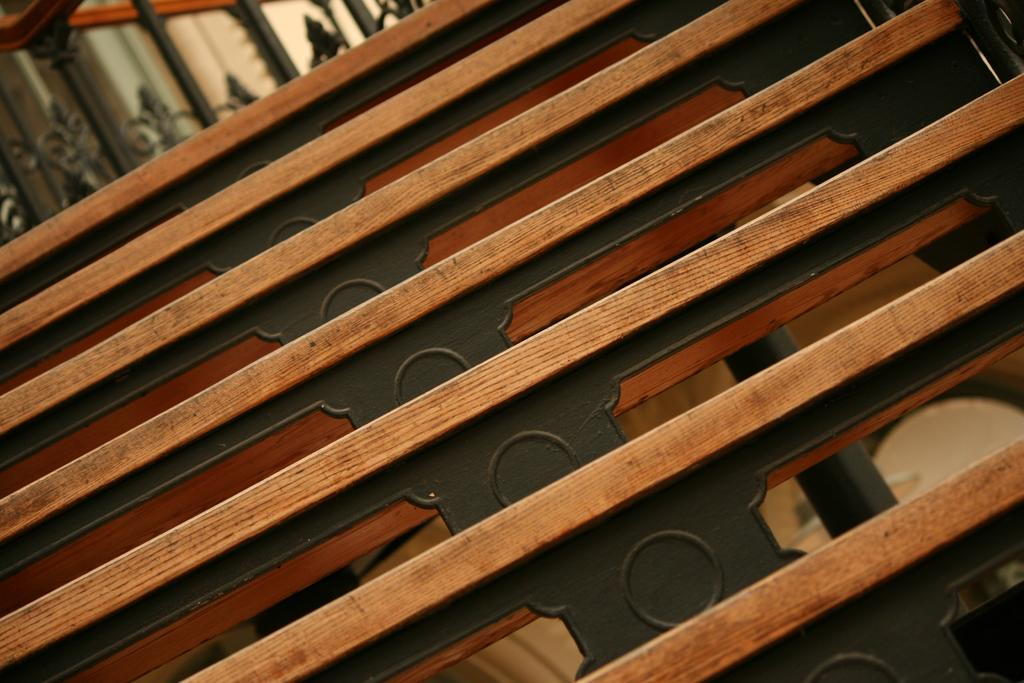What material is the bench in the image made of? The bench in the image is made of wood. What can be seen in the background of the image? There is a metal railing in the background of the image. Where is the sponge located in the image? There is no sponge present in the image. What type of mine is depicted in the image? There is no mine present in the image. 